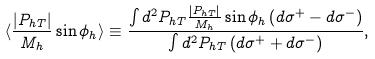Convert formula to latex. <formula><loc_0><loc_0><loc_500><loc_500>\langle \frac { { | P _ { h T } | } } { M _ { h } } \sin \phi _ { h } \rangle \equiv \frac { \int d ^ { 2 } P _ { h T } \frac { { | P _ { h T } | } } { M _ { h } } \sin \phi _ { h } \left ( d \sigma ^ { + } - d \sigma ^ { - } \right ) } { \int d ^ { 2 } P _ { h T } \left ( d \sigma ^ { + } + d \sigma ^ { - } \right ) } ,</formula> 